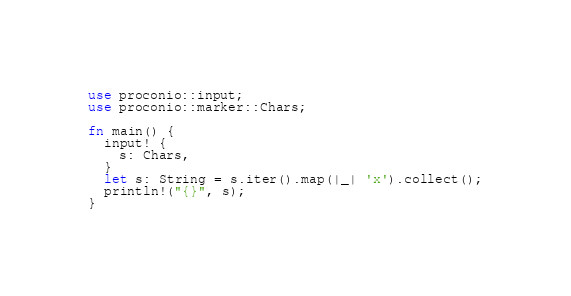Convert code to text. <code><loc_0><loc_0><loc_500><loc_500><_Rust_>use proconio::input;
use proconio::marker::Chars;

fn main() {
  input! {
    s: Chars,
  }
  let s: String = s.iter().map(|_| 'x').collect();
  println!("{}", s);
}
</code> 